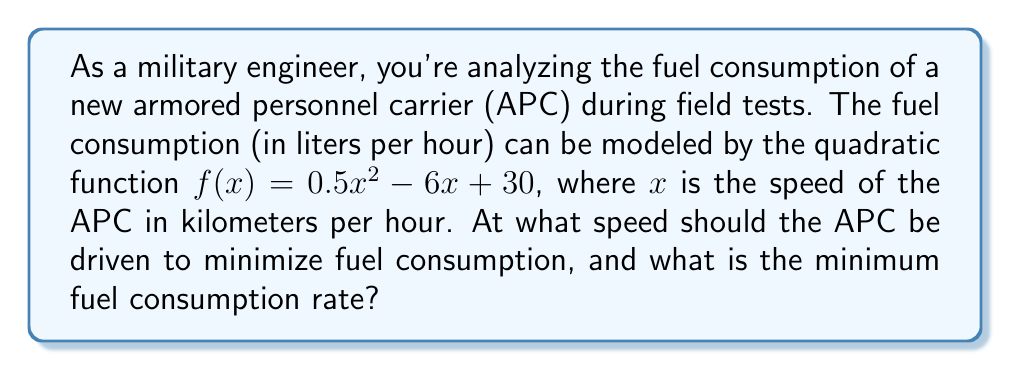Help me with this question. To solve this problem, we need to follow these steps:

1) The quadratic function given is $f(x) = 0.5x^2 - 6x + 30$, where $f(x)$ is the fuel consumption in liters per hour and $x$ is the speed in km/h.

2) To find the minimum point of a quadratic function, we need to find the vertex of the parabola. For a quadratic function in the form $f(x) = ax^2 + bx + c$, the x-coordinate of the vertex is given by $x = -\frac{b}{2a}$.

3) In this case, $a = 0.5$, $b = -6$, and $c = 30$. Let's calculate the x-coordinate of the vertex:

   $x = -\frac{b}{2a} = -\frac{-6}{2(0.5)} = -\frac{-6}{1} = 6$

4) This means the APC should be driven at 6 km/h to minimize fuel consumption.

5) To find the minimum fuel consumption rate, we need to calculate $f(6)$:

   $f(6) = 0.5(6)^2 - 6(6) + 30$
   $= 0.5(36) - 36 + 30$
   $= 18 - 36 + 30$
   $= 12$

Therefore, the minimum fuel consumption rate is 12 liters per hour.
Answer: The APC should be driven at 6 km/h to minimize fuel consumption, and the minimum fuel consumption rate is 12 liters per hour. 